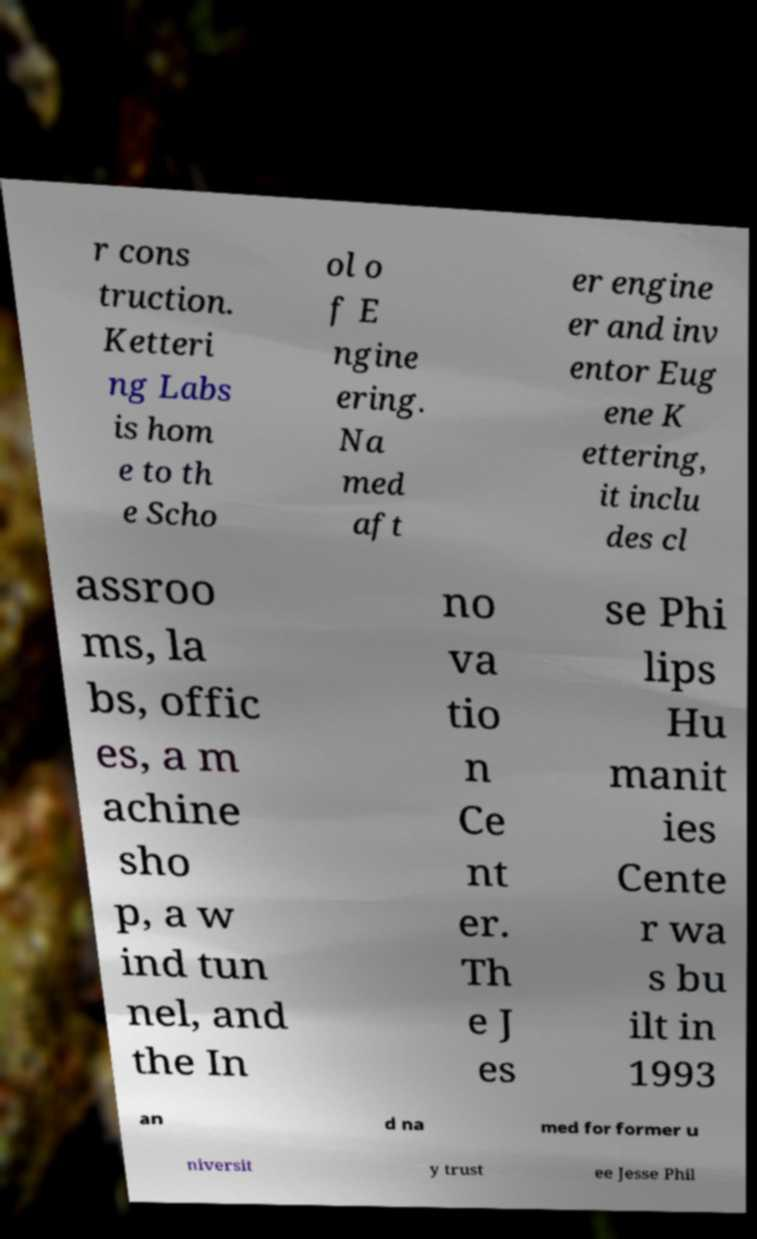What messages or text are displayed in this image? I need them in a readable, typed format. r cons truction. Ketteri ng Labs is hom e to th e Scho ol o f E ngine ering. Na med aft er engine er and inv entor Eug ene K ettering, it inclu des cl assroo ms, la bs, offic es, a m achine sho p, a w ind tun nel, and the In no va tio n Ce nt er. Th e J es se Phi lips Hu manit ies Cente r wa s bu ilt in 1993 an d na med for former u niversit y trust ee Jesse Phil 